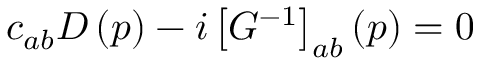<formula> <loc_0><loc_0><loc_500><loc_500>c _ { a b } D \left ( p \right ) - i \left [ G ^ { - 1 } \right ] _ { a b } \left ( p \right ) = 0</formula> 